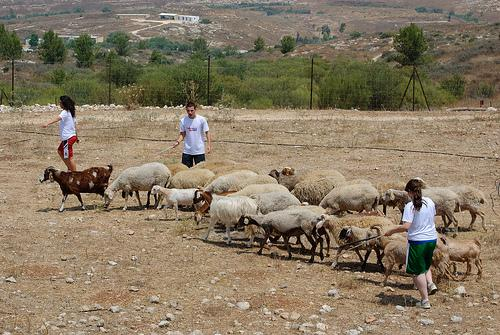Question: why are they corralling the sheep?
Choices:
A. To sheer.
B. To get to one location.
C. To feed.
D. To steal.
Answer with the letter. Answer: B Question: what is in the background?
Choices:
A. Valley.
B. Mountain.
C. Ocean.
D. Building.
Answer with the letter. Answer: A Question: what are they walking on?
Choices:
A. Asphalt.
B. Stairs.
C. Dirt and rocks.
D. Sand.
Answer with the letter. Answer: C Question: how many men are there?
Choices:
A. Four.
B. Five.
C. Three.
D. Six.
Answer with the letter. Answer: C Question: where is this location?
Choices:
A. Parking lot.
B. Field.
C. Building.
D. City.
Answer with the letter. Answer: B 